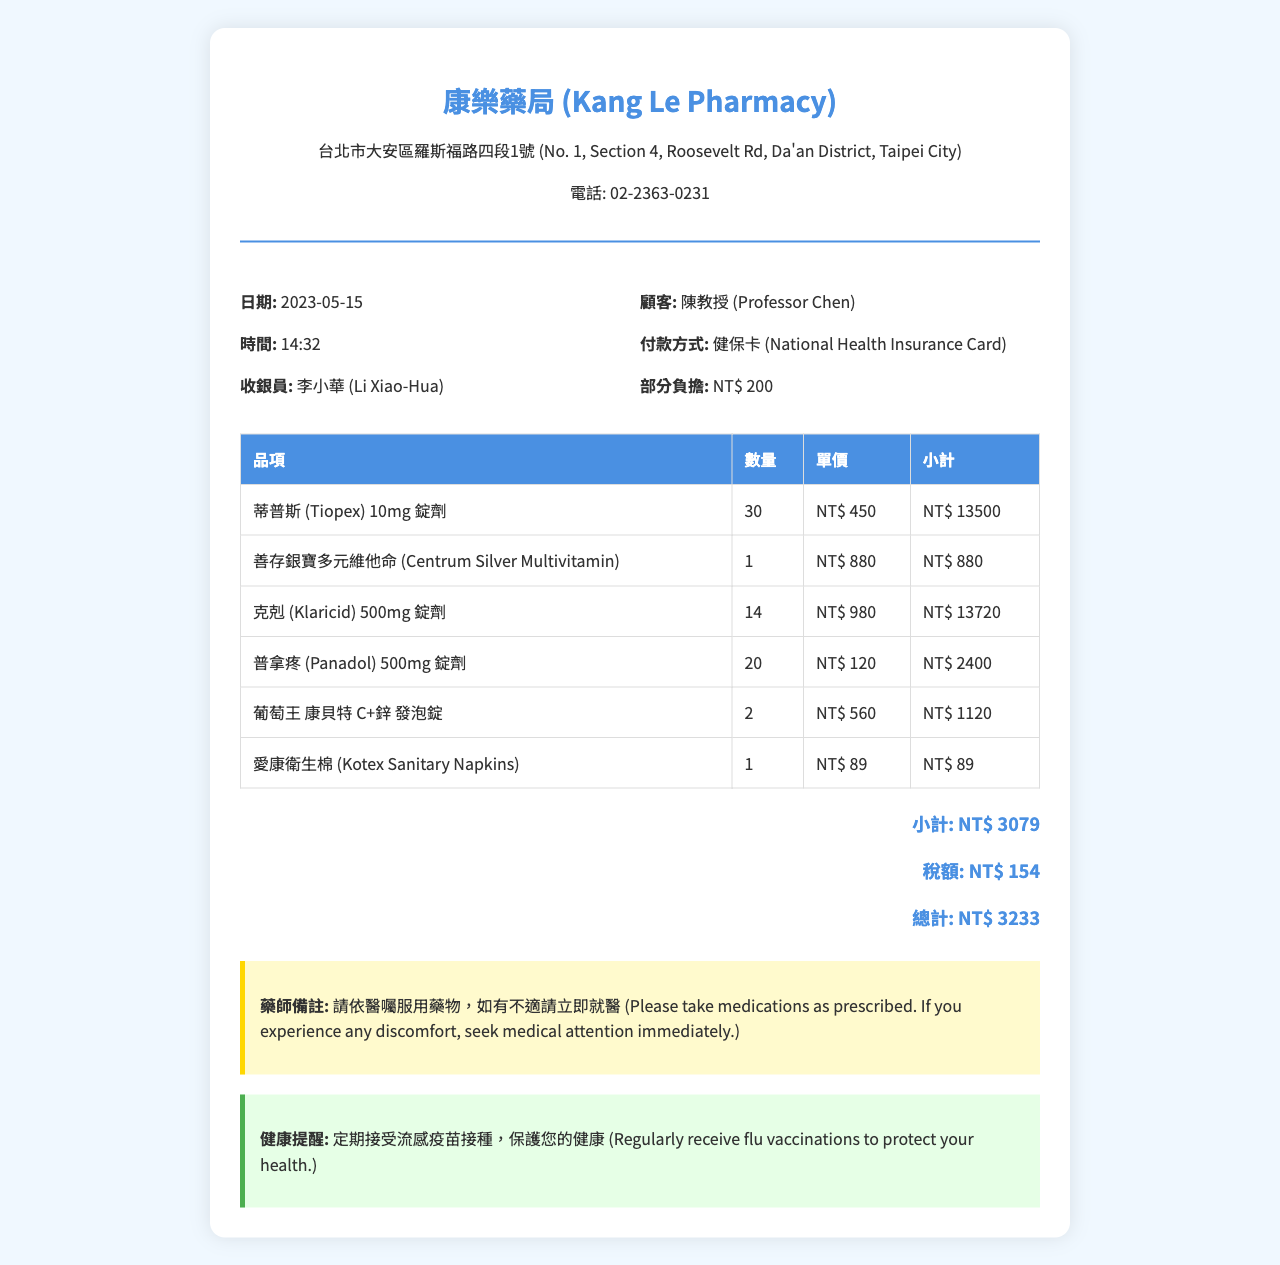What is the name of the pharmacy? The pharmacy's name is listed at the top of the receipt.
Answer: 康樂藥局 (Kang Le Pharmacy) What is the total amount due? The total amount due is provided at the bottom of the receipt.
Answer: NT$ 3233 How many units of Tiopex were purchased? The receipt provides the quantity of each item purchased.
Answer: 30 What is the price of Centrum Silver Multivitamin? The receipt lists the price next to each item, including the vitamins.
Answer: NT$ 880 Who is the cashier for this transaction? The cashier's name is mentioned in the details section of the receipt.
Answer: 李小華 (Li Xiao-Hua) What was the copayment amount? The copayment amount is clearly stated on the receipt.
Answer: NT$ 200 What is the date of the transaction? The date of the transaction is provided in the information section.
Answer: 2023-05-15 What health reminder is provided by the pharmacy? The health reminder is found in the designated section toward the end of the receipt.
Answer: 定期接受流感疫苗接種，保護您的健康 What note did the pharmacist include? The pharmacist's note is included in the comments section of the receipt.
Answer: 請依醫囑服用藥物，如有不適請立即就醫 